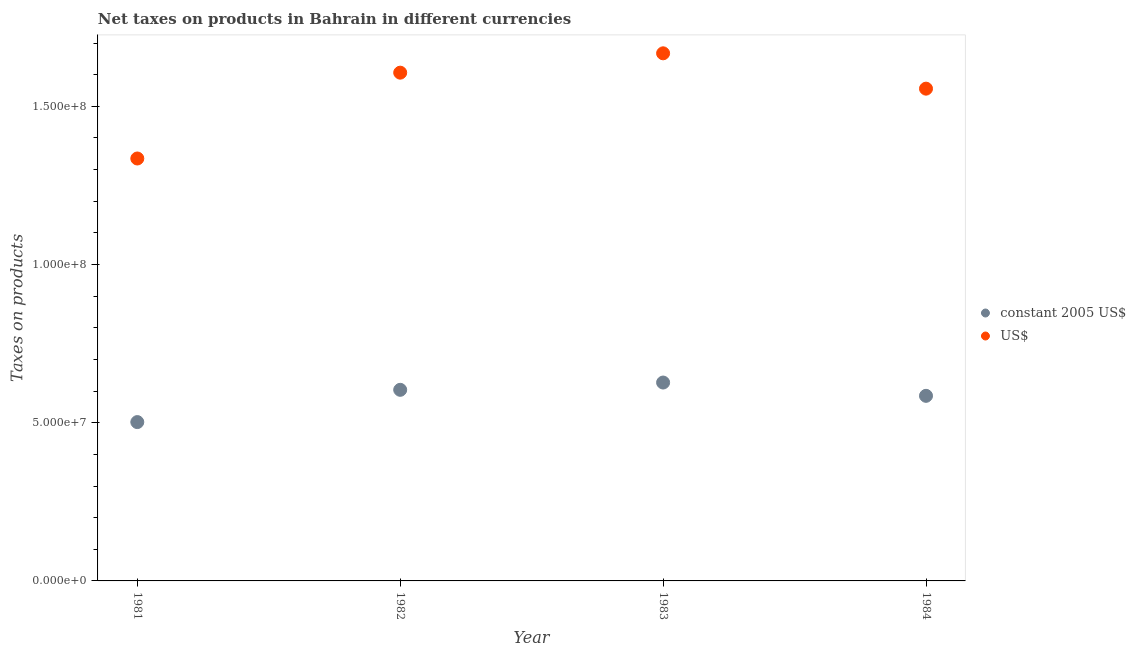How many different coloured dotlines are there?
Ensure brevity in your answer.  2. What is the net taxes in constant 2005 us$ in 1981?
Make the answer very short. 5.02e+07. Across all years, what is the maximum net taxes in us$?
Your answer should be very brief. 1.67e+08. Across all years, what is the minimum net taxes in constant 2005 us$?
Keep it short and to the point. 5.02e+07. In which year was the net taxes in us$ maximum?
Give a very brief answer. 1983. What is the total net taxes in constant 2005 us$ in the graph?
Offer a very short reply. 2.32e+08. What is the difference between the net taxes in constant 2005 us$ in 1981 and that in 1982?
Your answer should be compact. -1.02e+07. What is the difference between the net taxes in us$ in 1981 and the net taxes in constant 2005 us$ in 1983?
Make the answer very short. 7.08e+07. What is the average net taxes in constant 2005 us$ per year?
Offer a terse response. 5.80e+07. In the year 1982, what is the difference between the net taxes in constant 2005 us$ and net taxes in us$?
Make the answer very short. -1.00e+08. What is the ratio of the net taxes in us$ in 1982 to that in 1984?
Your response must be concise. 1.03. Is the net taxes in us$ in 1982 less than that in 1983?
Offer a terse response. Yes. What is the difference between the highest and the second highest net taxes in us$?
Provide a short and direct response. 6.12e+06. What is the difference between the highest and the lowest net taxes in constant 2005 us$?
Offer a very short reply. 1.25e+07. Is the sum of the net taxes in constant 2005 us$ in 1982 and 1984 greater than the maximum net taxes in us$ across all years?
Give a very brief answer. No. Is the net taxes in us$ strictly less than the net taxes in constant 2005 us$ over the years?
Offer a very short reply. No. Does the graph contain any zero values?
Make the answer very short. No. Where does the legend appear in the graph?
Offer a very short reply. Center right. How many legend labels are there?
Your answer should be very brief. 2. What is the title of the graph?
Offer a terse response. Net taxes on products in Bahrain in different currencies. What is the label or title of the X-axis?
Give a very brief answer. Year. What is the label or title of the Y-axis?
Offer a terse response. Taxes on products. What is the Taxes on products of constant 2005 US$ in 1981?
Offer a very short reply. 5.02e+07. What is the Taxes on products in US$ in 1981?
Offer a very short reply. 1.34e+08. What is the Taxes on products in constant 2005 US$ in 1982?
Your response must be concise. 6.04e+07. What is the Taxes on products in US$ in 1982?
Offer a very short reply. 1.61e+08. What is the Taxes on products in constant 2005 US$ in 1983?
Offer a very short reply. 6.27e+07. What is the Taxes on products of US$ in 1983?
Your response must be concise. 1.67e+08. What is the Taxes on products of constant 2005 US$ in 1984?
Make the answer very short. 5.85e+07. What is the Taxes on products of US$ in 1984?
Keep it short and to the point. 1.56e+08. Across all years, what is the maximum Taxes on products of constant 2005 US$?
Offer a very short reply. 6.27e+07. Across all years, what is the maximum Taxes on products of US$?
Make the answer very short. 1.67e+08. Across all years, what is the minimum Taxes on products in constant 2005 US$?
Give a very brief answer. 5.02e+07. Across all years, what is the minimum Taxes on products in US$?
Your response must be concise. 1.34e+08. What is the total Taxes on products in constant 2005 US$ in the graph?
Make the answer very short. 2.32e+08. What is the total Taxes on products of US$ in the graph?
Give a very brief answer. 6.16e+08. What is the difference between the Taxes on products in constant 2005 US$ in 1981 and that in 1982?
Give a very brief answer. -1.02e+07. What is the difference between the Taxes on products in US$ in 1981 and that in 1982?
Make the answer very short. -2.71e+07. What is the difference between the Taxes on products in constant 2005 US$ in 1981 and that in 1983?
Provide a succinct answer. -1.25e+07. What is the difference between the Taxes on products of US$ in 1981 and that in 1983?
Your answer should be very brief. -3.32e+07. What is the difference between the Taxes on products of constant 2005 US$ in 1981 and that in 1984?
Keep it short and to the point. -8.30e+06. What is the difference between the Taxes on products of US$ in 1981 and that in 1984?
Offer a terse response. -2.21e+07. What is the difference between the Taxes on products of constant 2005 US$ in 1982 and that in 1983?
Give a very brief answer. -2.30e+06. What is the difference between the Taxes on products in US$ in 1982 and that in 1983?
Offer a terse response. -6.12e+06. What is the difference between the Taxes on products in constant 2005 US$ in 1982 and that in 1984?
Your answer should be very brief. 1.90e+06. What is the difference between the Taxes on products of US$ in 1982 and that in 1984?
Keep it short and to the point. 5.05e+06. What is the difference between the Taxes on products of constant 2005 US$ in 1983 and that in 1984?
Give a very brief answer. 4.20e+06. What is the difference between the Taxes on products of US$ in 1983 and that in 1984?
Ensure brevity in your answer.  1.12e+07. What is the difference between the Taxes on products in constant 2005 US$ in 1981 and the Taxes on products in US$ in 1982?
Ensure brevity in your answer.  -1.10e+08. What is the difference between the Taxes on products in constant 2005 US$ in 1981 and the Taxes on products in US$ in 1983?
Offer a terse response. -1.17e+08. What is the difference between the Taxes on products of constant 2005 US$ in 1981 and the Taxes on products of US$ in 1984?
Offer a very short reply. -1.05e+08. What is the difference between the Taxes on products of constant 2005 US$ in 1982 and the Taxes on products of US$ in 1983?
Give a very brief answer. -1.06e+08. What is the difference between the Taxes on products of constant 2005 US$ in 1982 and the Taxes on products of US$ in 1984?
Offer a terse response. -9.52e+07. What is the difference between the Taxes on products in constant 2005 US$ in 1983 and the Taxes on products in US$ in 1984?
Your answer should be very brief. -9.29e+07. What is the average Taxes on products in constant 2005 US$ per year?
Offer a terse response. 5.80e+07. What is the average Taxes on products of US$ per year?
Your response must be concise. 1.54e+08. In the year 1981, what is the difference between the Taxes on products in constant 2005 US$ and Taxes on products in US$?
Provide a short and direct response. -8.33e+07. In the year 1982, what is the difference between the Taxes on products in constant 2005 US$ and Taxes on products in US$?
Keep it short and to the point. -1.00e+08. In the year 1983, what is the difference between the Taxes on products of constant 2005 US$ and Taxes on products of US$?
Your response must be concise. -1.04e+08. In the year 1984, what is the difference between the Taxes on products in constant 2005 US$ and Taxes on products in US$?
Offer a very short reply. -9.71e+07. What is the ratio of the Taxes on products in constant 2005 US$ in 1981 to that in 1982?
Offer a terse response. 0.83. What is the ratio of the Taxes on products in US$ in 1981 to that in 1982?
Provide a succinct answer. 0.83. What is the ratio of the Taxes on products in constant 2005 US$ in 1981 to that in 1983?
Provide a succinct answer. 0.8. What is the ratio of the Taxes on products in US$ in 1981 to that in 1983?
Give a very brief answer. 0.8. What is the ratio of the Taxes on products in constant 2005 US$ in 1981 to that in 1984?
Give a very brief answer. 0.86. What is the ratio of the Taxes on products of US$ in 1981 to that in 1984?
Provide a succinct answer. 0.86. What is the ratio of the Taxes on products in constant 2005 US$ in 1982 to that in 1983?
Give a very brief answer. 0.96. What is the ratio of the Taxes on products of US$ in 1982 to that in 1983?
Your answer should be compact. 0.96. What is the ratio of the Taxes on products in constant 2005 US$ in 1982 to that in 1984?
Your answer should be compact. 1.03. What is the ratio of the Taxes on products of US$ in 1982 to that in 1984?
Provide a succinct answer. 1.03. What is the ratio of the Taxes on products of constant 2005 US$ in 1983 to that in 1984?
Offer a terse response. 1.07. What is the ratio of the Taxes on products in US$ in 1983 to that in 1984?
Offer a terse response. 1.07. What is the difference between the highest and the second highest Taxes on products of constant 2005 US$?
Your answer should be very brief. 2.30e+06. What is the difference between the highest and the second highest Taxes on products of US$?
Provide a succinct answer. 6.12e+06. What is the difference between the highest and the lowest Taxes on products in constant 2005 US$?
Your answer should be compact. 1.25e+07. What is the difference between the highest and the lowest Taxes on products of US$?
Offer a very short reply. 3.32e+07. 